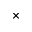Convert formula to latex. <formula><loc_0><loc_0><loc_500><loc_500>\times</formula> 